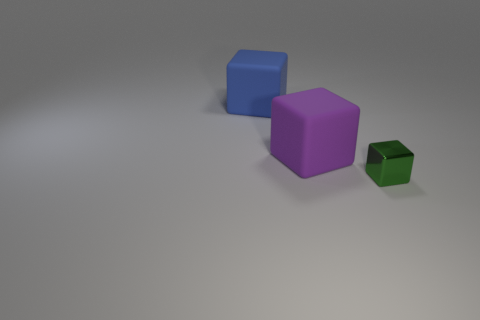Add 1 metal things. How many objects exist? 4 Add 1 tiny green metallic blocks. How many tiny green metallic blocks are left? 2 Add 3 shiny cubes. How many shiny cubes exist? 4 Subtract 0 gray cubes. How many objects are left? 3 Subtract all big yellow metallic objects. Subtract all metal objects. How many objects are left? 2 